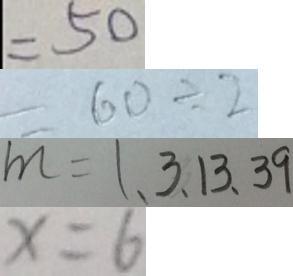Convert formula to latex. <formula><loc_0><loc_0><loc_500><loc_500>= 5 0 
 = 6 0 \div 2 
 m = 1 、 3 、 1 3 、 3 9 
 x = 6</formula> 